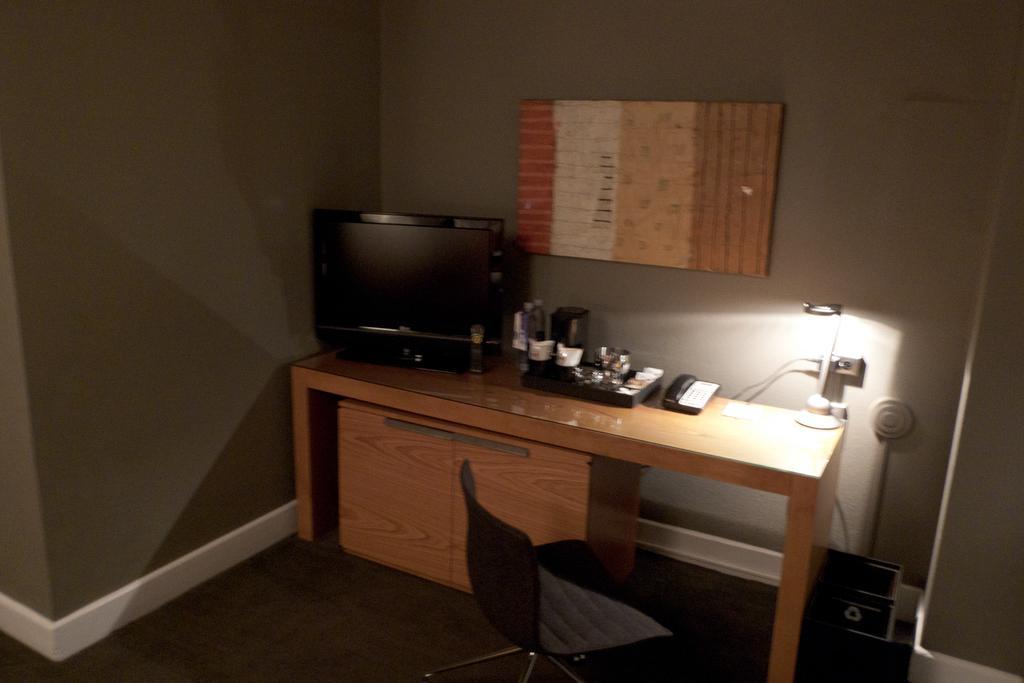How would you summarize this image in a sentence or two? In the picture I can see a chair, table upon which telephone, television, a table lamp and few more things are places, I can see wooden cupboards, some objects and the frame fixed to the wall in the background. 